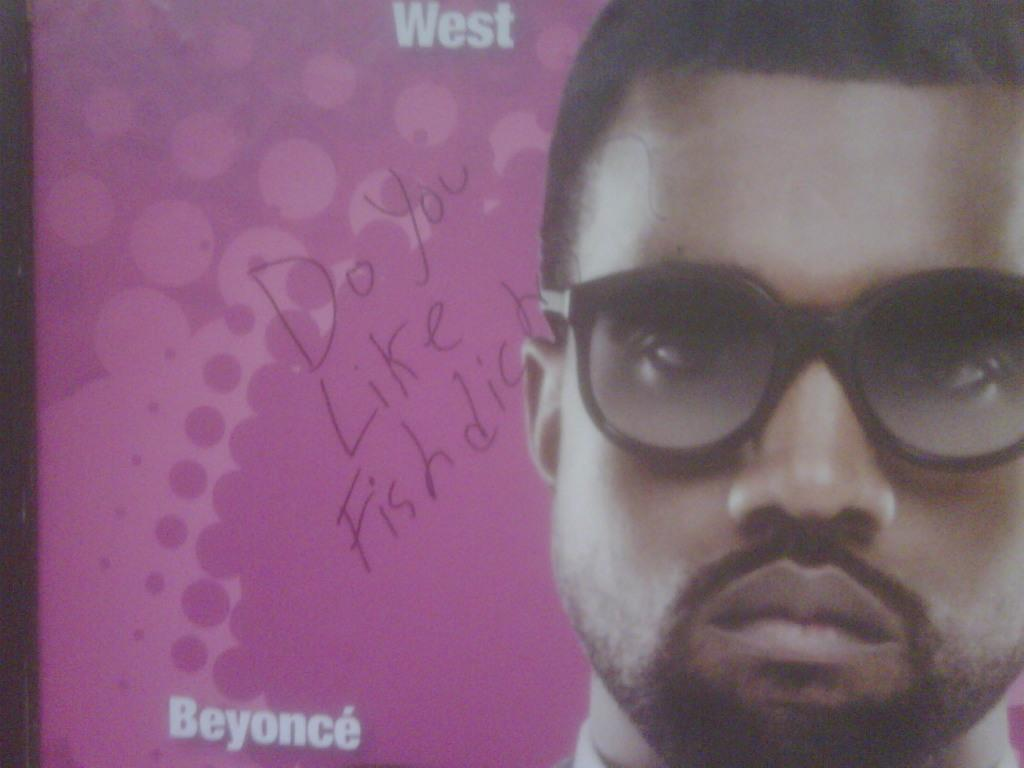What can be seen on the right side of the image? There is a person wearing spectacles on the right side of the image. What is depicted on the left side of the image? There are white and other colored texts and designs on the left side of the poster. What color is the background of the image? The background of the image is pink in color. Can you tell me how many jars are on the person's head in the image? There are no jars present on the person's head in the image. What type of club does the lawyer belong to in the image? There is no lawyer or club present in the image. 